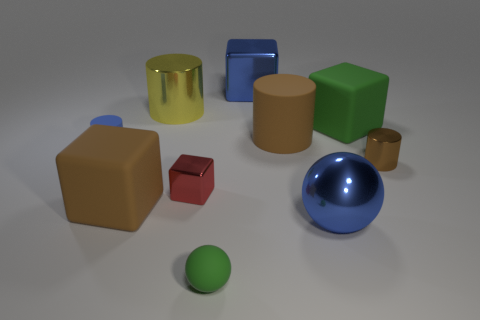Subtract all tiny rubber cylinders. How many cylinders are left? 3 Subtract all green balls. How many balls are left? 1 Subtract all blocks. How many objects are left? 6 Subtract all red spheres. Subtract all gray blocks. How many spheres are left? 2 Subtract all green cylinders. How many brown spheres are left? 0 Subtract all red objects. Subtract all brown metal cylinders. How many objects are left? 8 Add 9 red things. How many red things are left? 10 Add 5 big brown objects. How many big brown objects exist? 7 Subtract 0 green cylinders. How many objects are left? 10 Subtract 3 cubes. How many cubes are left? 1 